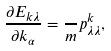Convert formula to latex. <formula><loc_0><loc_0><loc_500><loc_500>\frac { \partial E _ { k \lambda } } { \partial k _ { \alpha } } = \frac { } { m } p ^ { k } _ { \lambda \lambda } ,</formula> 